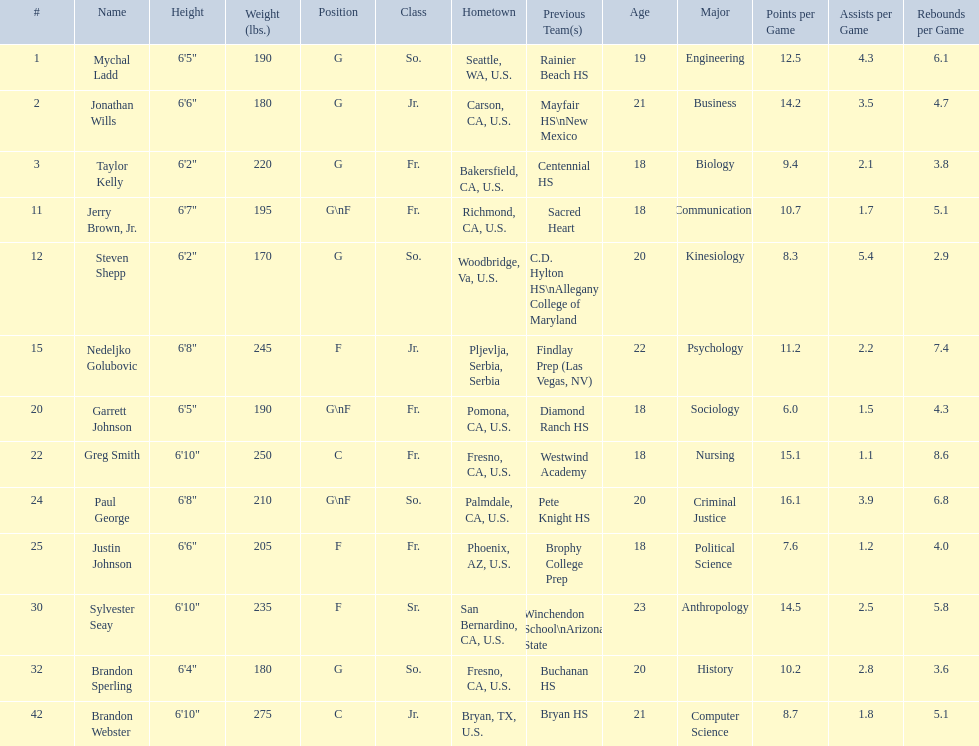Who is the next heaviest player after nedelijko golubovic? Sylvester Seay. 